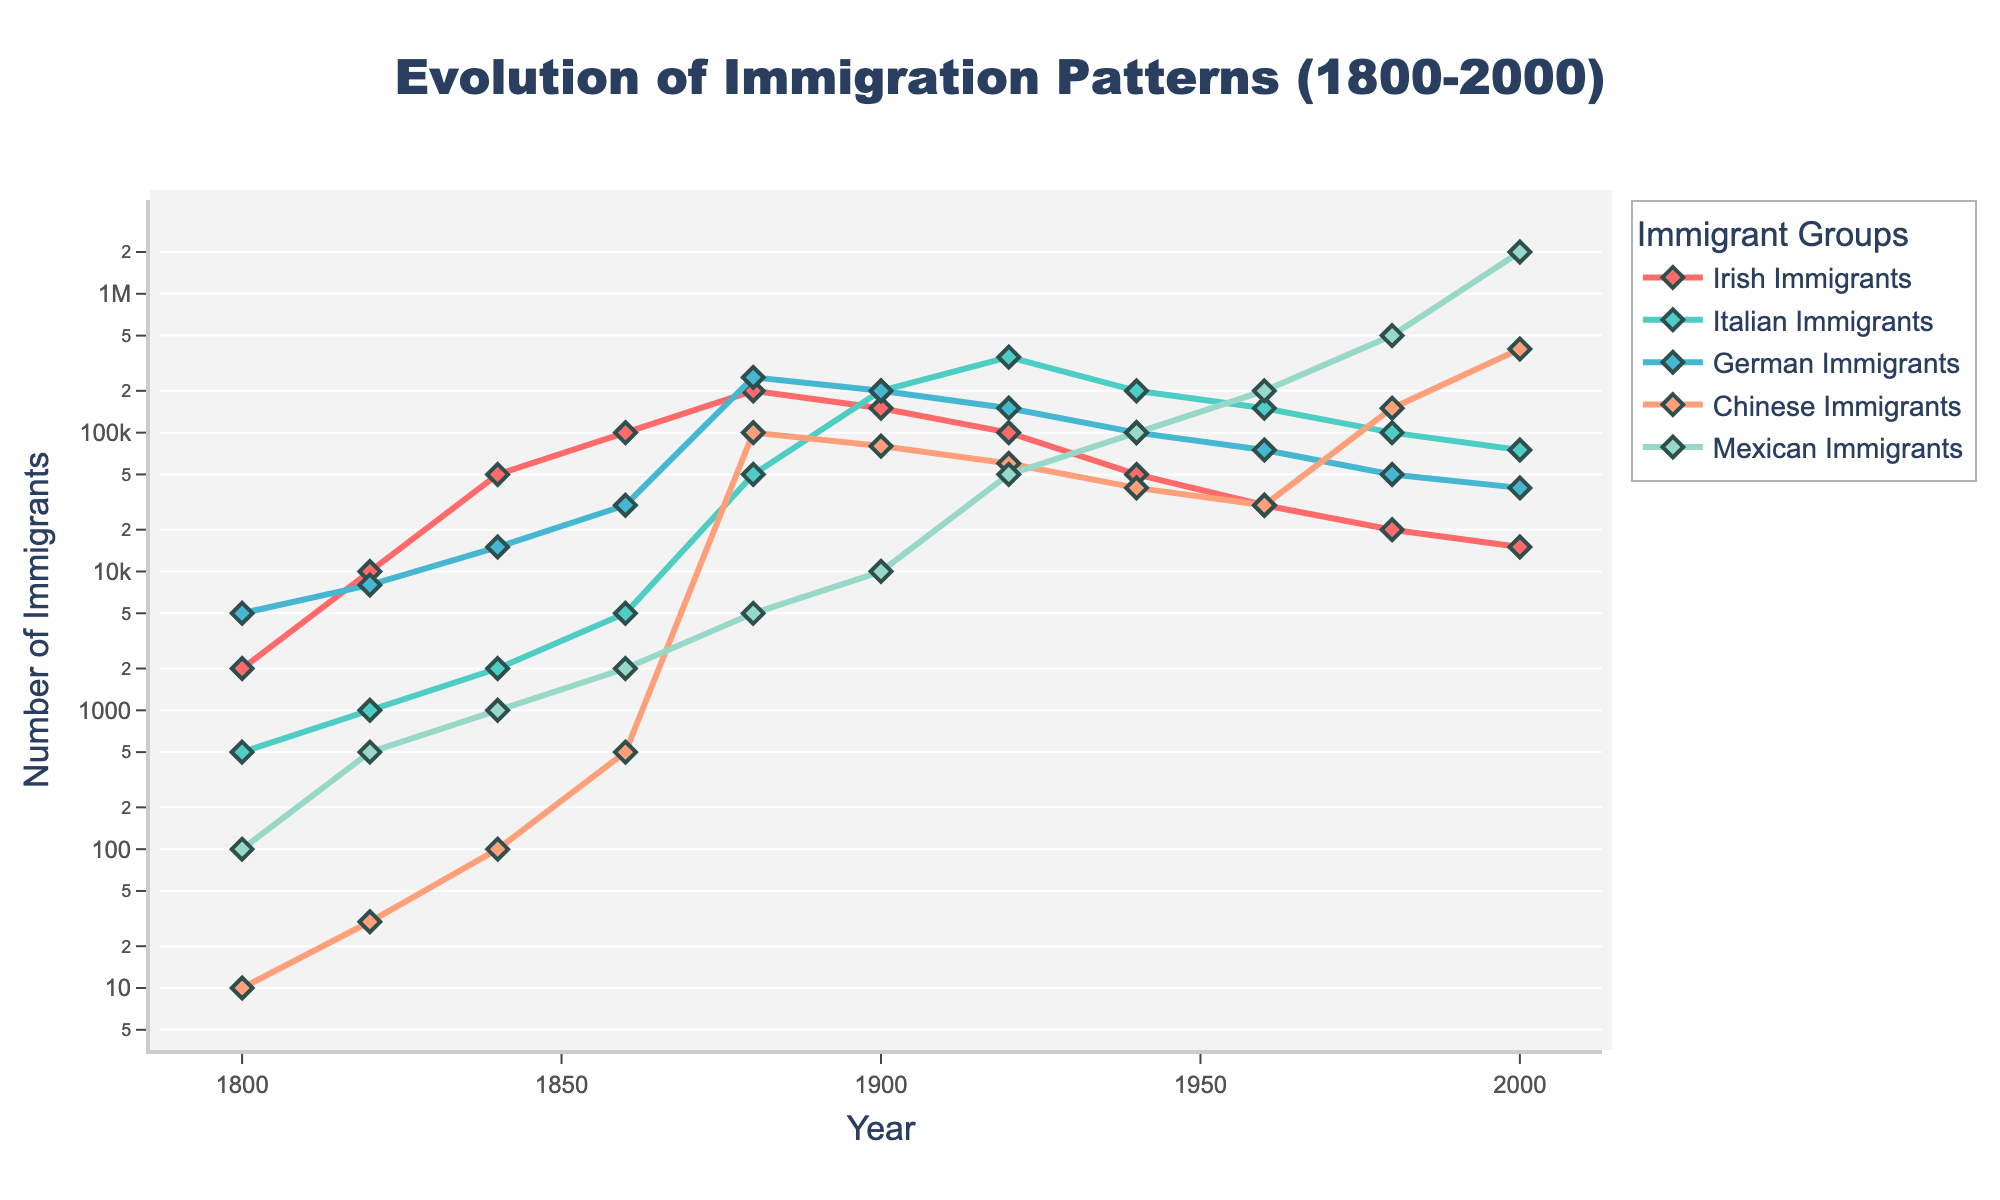What trend is observed in the number of Irish immigrants between 1800 and 2000? The number of Irish immigrants increases from 2000 in 1800 to a peak of 200000 in 1880, and then it generally decreases to 15000 in 2000.
Answer: Decreasing after 1880 Which immigrant group had the highest number in 2000? In the year 2000, Mexican Immigrants had the highest number at 2000000, significantly higher than any other group.
Answer: Mexican Immigrants During which period did Chinese immigrant numbers increase most rapidly? Between 1960 and 1980, Chinese immigration increased from 30000 to 150000, the most rapid increase compared to other periods.
Answer: 1960 to 1980 Compare the number of Italian immigrants in 1900 and 1920. In 1900, there were 200000 Italian immigrants, and in 1920, it increased to 350000, so there was an increase of 150000.
Answer: Increased by 150000 What is the total number of German immigrants from 1800 to 2000? Summing up the German immigrants over the years: 5000 + 8000 + 15000 + 30000 + 250000 + 200000 + 150000 + 100000 + 75000 + 50000 + 40000 = 973000.
Answer: 973000 Which group peaked exactly in 1880? The German immigrant group saw its peak in 1880 with 250000 immigrants.
Answer: German Immigrants What is the highest immigration number recorded and for which group and year? The highest recorded immigration number is for Mexican Immigrants in the year 2000 with 2000000 immigrants.
Answer: Mexican Immigrants in 2000 How does the number of Mexican immigrants in 1980 compare with that of Irish immigrants in 1800? In 1980, there were 500000 Mexican immigrants, whereas in 1800, there were 2000 Irish immigrants, so Mexican immigrants in 1980 outnumbered Irish immigrants in 1800 by 498000.
Answer: Outnumbered by 498000 Which group shows a peak annotation on the figure, and what does it indicate? The figure has a peak annotation for Italian Immigrants around the year 1900, indicating the peak of Italian immigration at that time.
Answer: Italian Immigrants in 1900 What are the three highest peaks for the Italian Immigrants based on the figure? The three highest peaks of Italian Immigrants in the figure are in 1920 (350000), 1900 (200000), and 1880 (50000).
Answer: 1920, 1900, 1880 